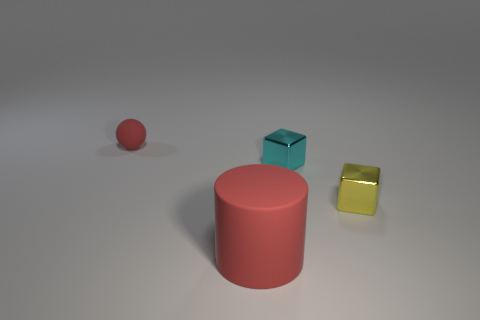Add 1 small red rubber spheres. How many objects exist? 5 Subtract all cylinders. How many objects are left? 3 Add 3 large matte cylinders. How many large matte cylinders exist? 4 Subtract 0 brown cylinders. How many objects are left? 4 Subtract all small yellow things. Subtract all large green metallic cylinders. How many objects are left? 3 Add 3 red rubber things. How many red rubber things are left? 5 